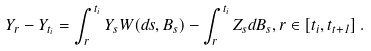Convert formula to latex. <formula><loc_0><loc_0><loc_500><loc_500>Y _ { r } - Y _ { t _ { i } } = \int _ { r } ^ { t _ { i } } Y _ { s } W ( d s , B _ { s } ) - \int _ { r } ^ { t _ { i } } Z _ { s } d B _ { s } , r \in [ { t _ { i } } , t _ { t + 1 } ] \, .</formula> 